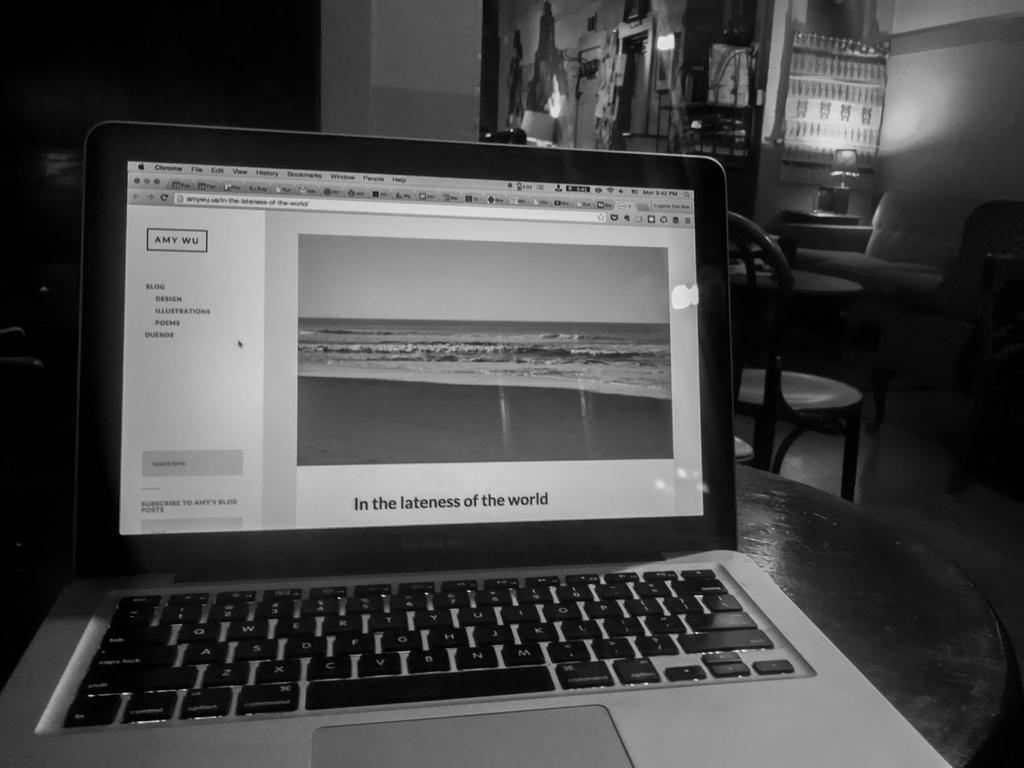Provide a one-sentence caption for the provided image. a laptop with 'in the lateness of the world' on the screen. 